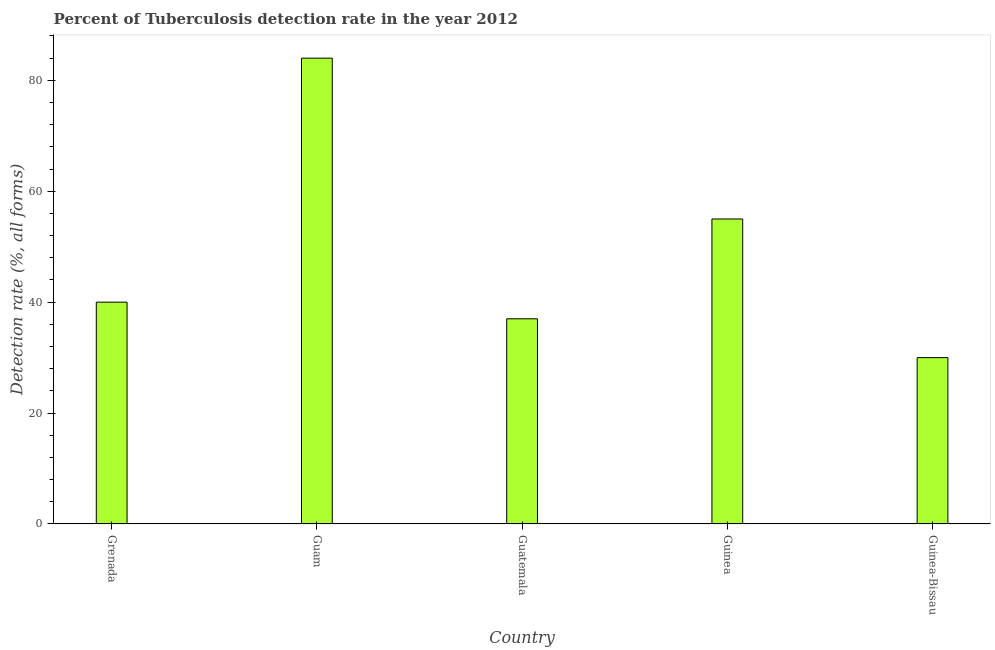Does the graph contain any zero values?
Provide a short and direct response. No. What is the title of the graph?
Ensure brevity in your answer.  Percent of Tuberculosis detection rate in the year 2012. What is the label or title of the Y-axis?
Provide a short and direct response. Detection rate (%, all forms). What is the detection rate of tuberculosis in Guatemala?
Provide a succinct answer. 37. Across all countries, what is the maximum detection rate of tuberculosis?
Make the answer very short. 84. In which country was the detection rate of tuberculosis maximum?
Offer a very short reply. Guam. In which country was the detection rate of tuberculosis minimum?
Your response must be concise. Guinea-Bissau. What is the sum of the detection rate of tuberculosis?
Give a very brief answer. 246. What is the difference between the detection rate of tuberculosis in Grenada and Guinea?
Provide a succinct answer. -15. What is the average detection rate of tuberculosis per country?
Make the answer very short. 49. What is the median detection rate of tuberculosis?
Provide a succinct answer. 40. In how many countries, is the detection rate of tuberculosis greater than 52 %?
Keep it short and to the point. 2. What is the ratio of the detection rate of tuberculosis in Grenada to that in Guinea?
Your response must be concise. 0.73. Is the detection rate of tuberculosis in Guam less than that in Guatemala?
Your answer should be compact. No. What is the difference between the highest and the second highest detection rate of tuberculosis?
Ensure brevity in your answer.  29. In how many countries, is the detection rate of tuberculosis greater than the average detection rate of tuberculosis taken over all countries?
Your answer should be compact. 2. How many bars are there?
Ensure brevity in your answer.  5. How many countries are there in the graph?
Your answer should be compact. 5. What is the difference between two consecutive major ticks on the Y-axis?
Give a very brief answer. 20. What is the Detection rate (%, all forms) in Guam?
Offer a terse response. 84. What is the Detection rate (%, all forms) of Guatemala?
Offer a very short reply. 37. What is the Detection rate (%, all forms) in Guinea-Bissau?
Ensure brevity in your answer.  30. What is the difference between the Detection rate (%, all forms) in Grenada and Guam?
Ensure brevity in your answer.  -44. What is the difference between the Detection rate (%, all forms) in Grenada and Guatemala?
Ensure brevity in your answer.  3. What is the difference between the Detection rate (%, all forms) in Grenada and Guinea?
Provide a succinct answer. -15. What is the difference between the Detection rate (%, all forms) in Guam and Guinea?
Offer a terse response. 29. What is the difference between the Detection rate (%, all forms) in Guam and Guinea-Bissau?
Provide a short and direct response. 54. What is the ratio of the Detection rate (%, all forms) in Grenada to that in Guam?
Your response must be concise. 0.48. What is the ratio of the Detection rate (%, all forms) in Grenada to that in Guatemala?
Make the answer very short. 1.08. What is the ratio of the Detection rate (%, all forms) in Grenada to that in Guinea?
Provide a short and direct response. 0.73. What is the ratio of the Detection rate (%, all forms) in Grenada to that in Guinea-Bissau?
Make the answer very short. 1.33. What is the ratio of the Detection rate (%, all forms) in Guam to that in Guatemala?
Your response must be concise. 2.27. What is the ratio of the Detection rate (%, all forms) in Guam to that in Guinea?
Your response must be concise. 1.53. What is the ratio of the Detection rate (%, all forms) in Guam to that in Guinea-Bissau?
Give a very brief answer. 2.8. What is the ratio of the Detection rate (%, all forms) in Guatemala to that in Guinea?
Your answer should be compact. 0.67. What is the ratio of the Detection rate (%, all forms) in Guatemala to that in Guinea-Bissau?
Ensure brevity in your answer.  1.23. What is the ratio of the Detection rate (%, all forms) in Guinea to that in Guinea-Bissau?
Provide a short and direct response. 1.83. 